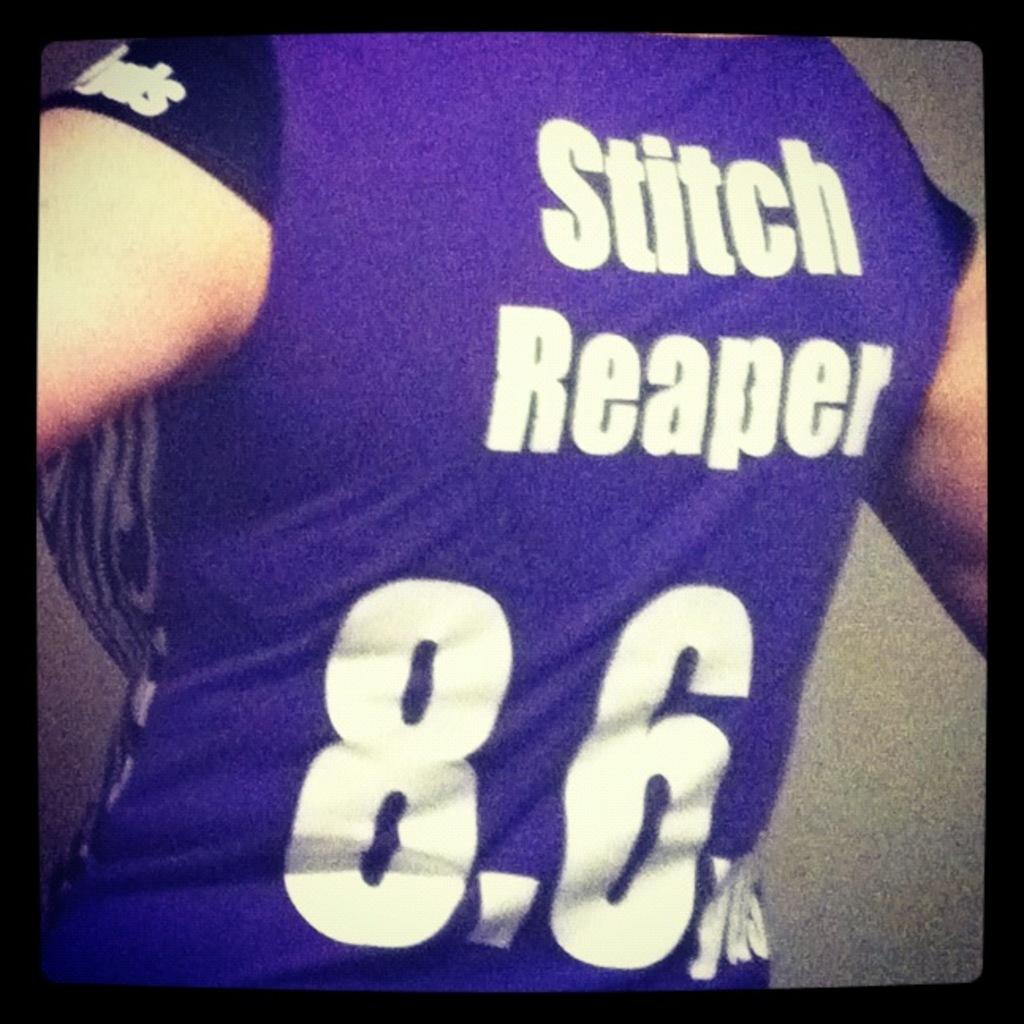What is present in the image? There is a person in the image. What is the person wearing? The person is wearing a t-shirt. What can be seen on the t-shirt? The t-shirt has text and numbers on it. What type of fan is visible in the image? There is no fan present in the image. How is the person using the fork in the image? There is no fork present in the image. 